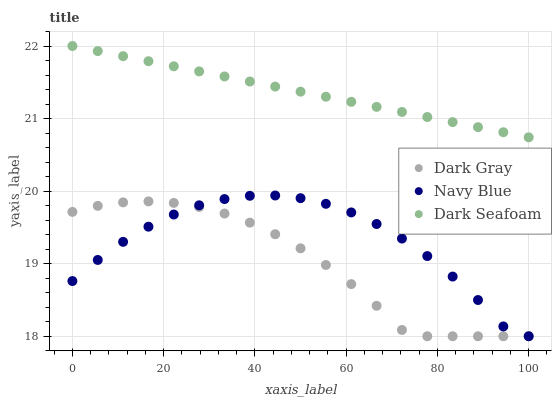Does Dark Gray have the minimum area under the curve?
Answer yes or no. Yes. Does Dark Seafoam have the maximum area under the curve?
Answer yes or no. Yes. Does Navy Blue have the minimum area under the curve?
Answer yes or no. No. Does Navy Blue have the maximum area under the curve?
Answer yes or no. No. Is Dark Seafoam the smoothest?
Answer yes or no. Yes. Is Navy Blue the roughest?
Answer yes or no. Yes. Is Navy Blue the smoothest?
Answer yes or no. No. Is Dark Seafoam the roughest?
Answer yes or no. No. Does Dark Gray have the lowest value?
Answer yes or no. Yes. Does Dark Seafoam have the lowest value?
Answer yes or no. No. Does Dark Seafoam have the highest value?
Answer yes or no. Yes. Does Navy Blue have the highest value?
Answer yes or no. No. Is Dark Gray less than Dark Seafoam?
Answer yes or no. Yes. Is Dark Seafoam greater than Dark Gray?
Answer yes or no. Yes. Does Navy Blue intersect Dark Gray?
Answer yes or no. Yes. Is Navy Blue less than Dark Gray?
Answer yes or no. No. Is Navy Blue greater than Dark Gray?
Answer yes or no. No. Does Dark Gray intersect Dark Seafoam?
Answer yes or no. No. 